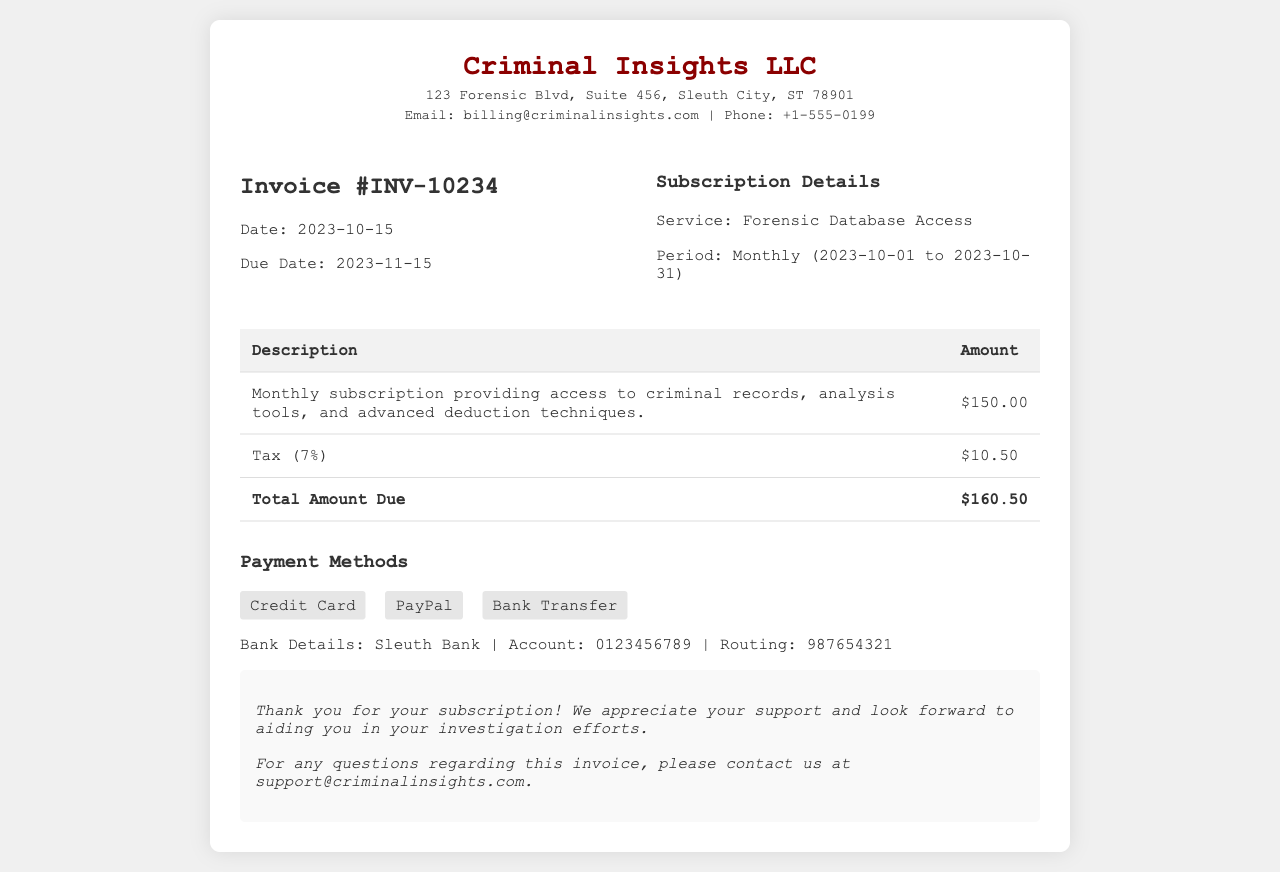what is the invoice number? The invoice number is specified at the top of the invoice document, which is INV-10234.
Answer: INV-10234 what is the total amount due? The total amount due is calculated based on the subscription fee and the tax, which totals to $160.50.
Answer: $160.50 who is the billing contact? The billing contact's email address is provided for inquiries, listed as billing@criminalinsights.com.
Answer: billing@criminalinsights.com what is the subscription period? The subscription period reflects the accessibility range for the service, from 2023-10-01 to 2023-10-31.
Answer: 2023-10-01 to 2023-10-31 how much is the tax percentage? The document specifies that the tax applied is 7%.
Answer: 7% when is the due date for payment? The due date for payment is provided in the invoice details, which is 2023-11-15.
Answer: 2023-11-15 what payment methods are accepted? The invoice lists multiple payment options, which are Credit Card, PayPal, and Bank Transfer.
Answer: Credit Card, PayPal, Bank Transfer what is the service provided? The service detailed in the invoice is labeled as Forensic Database Access.
Answer: Forensic Database Access what is the address of Criminal Insights LLC? The address stated in the invoice document is 123 Forensic Blvd, Suite 456, Sleuth City, ST 78901.
Answer: 123 Forensic Blvd, Suite 456, Sleuth City, ST 78901 